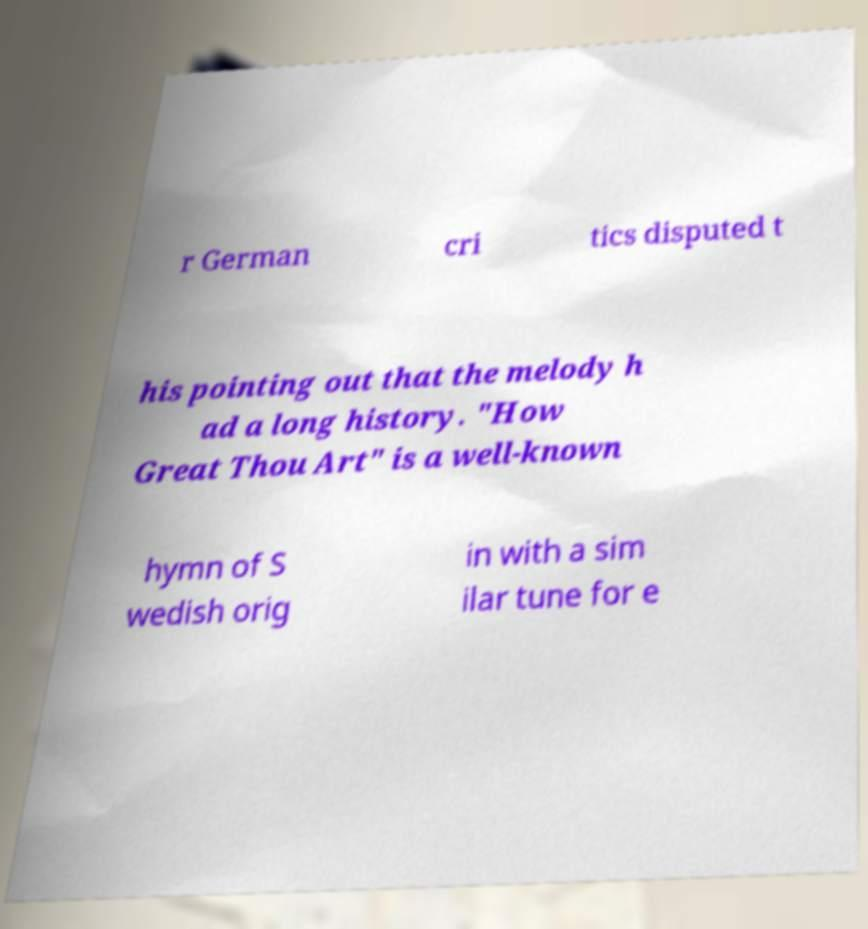Could you assist in decoding the text presented in this image and type it out clearly? r German cri tics disputed t his pointing out that the melody h ad a long history. "How Great Thou Art" is a well-known hymn of S wedish orig in with a sim ilar tune for e 